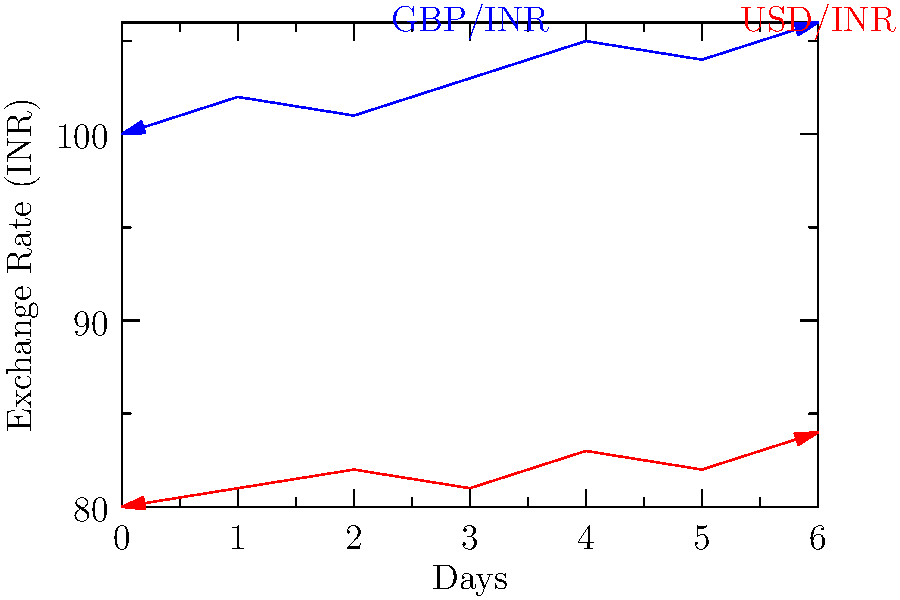You're planning to exchange some British Pounds (GBP) for Indian Rupees (INR) to send to your family in India. The graph shows the exchange rates for GBP/INR and USD/INR over a week. If you have £1000 to exchange, on which day would you get the most INR, and how much would you receive? To find the day when you'd get the most INR for £1000, we need to:

1. Identify the highest point on the GBP/INR line (blue).
2. Determine which day this occurs.
3. Calculate the amount of INR you'd receive on that day.

Step 1: The highest point on the GBP/INR line is at 106 INR per GBP.
Step 2: This occurs on day 6 (the last day shown on the graph).
Step 3: To calculate the amount of INR:
$$1000 \text{ GBP} \times 106 \text{ INR/GBP} = 106,000 \text{ INR}$$

Therefore, you would get the most INR by exchanging on day 6, receiving 106,000 INR for your £1000.
Answer: Day 6; 106,000 INR 